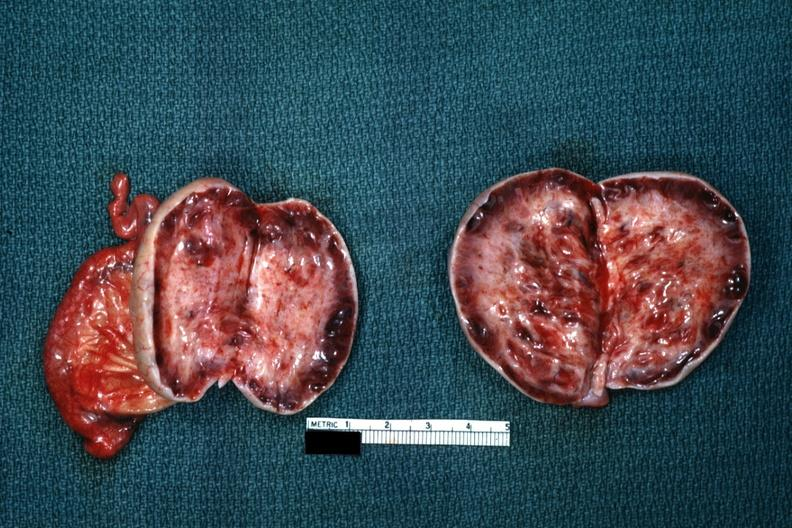s focal hemorrhagic infarction well shown present?
Answer the question using a single word or phrase. No 